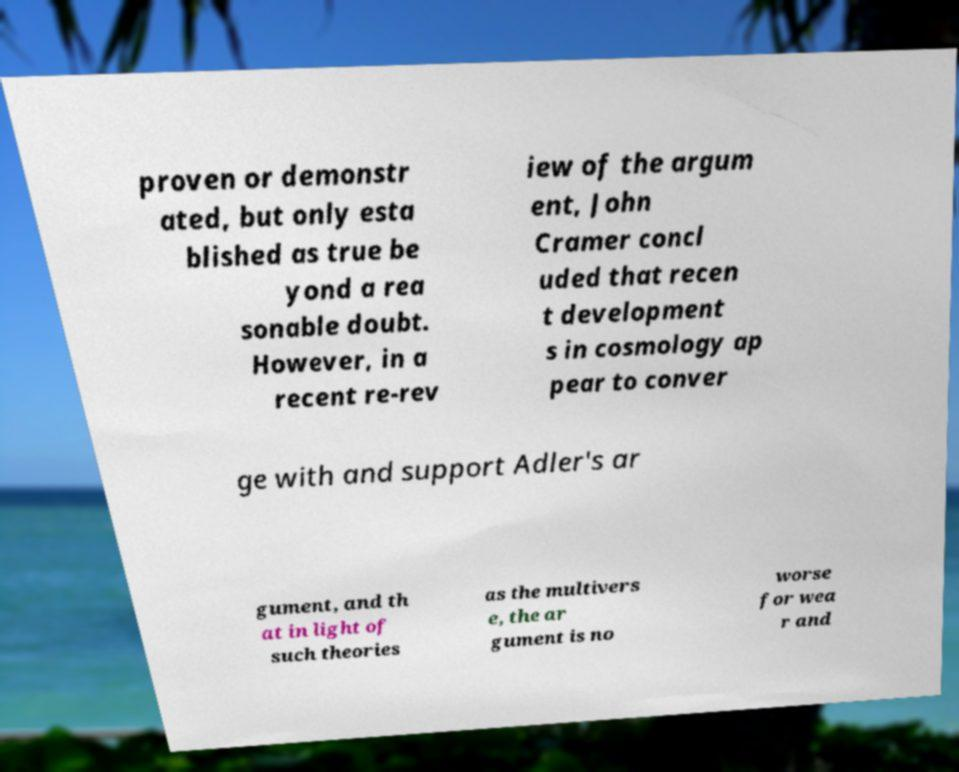What messages or text are displayed in this image? I need them in a readable, typed format. proven or demonstr ated, but only esta blished as true be yond a rea sonable doubt. However, in a recent re-rev iew of the argum ent, John Cramer concl uded that recen t development s in cosmology ap pear to conver ge with and support Adler's ar gument, and th at in light of such theories as the multivers e, the ar gument is no worse for wea r and 